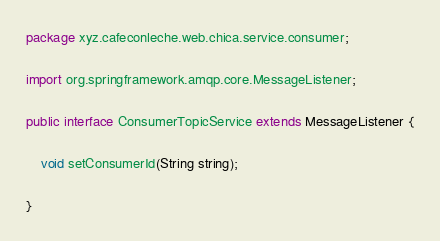Convert code to text. <code><loc_0><loc_0><loc_500><loc_500><_Java_>package xyz.cafeconleche.web.chica.service.consumer;

import org.springframework.amqp.core.MessageListener;

public interface ConsumerTopicService extends MessageListener {

	void setConsumerId(String string);

}
</code> 